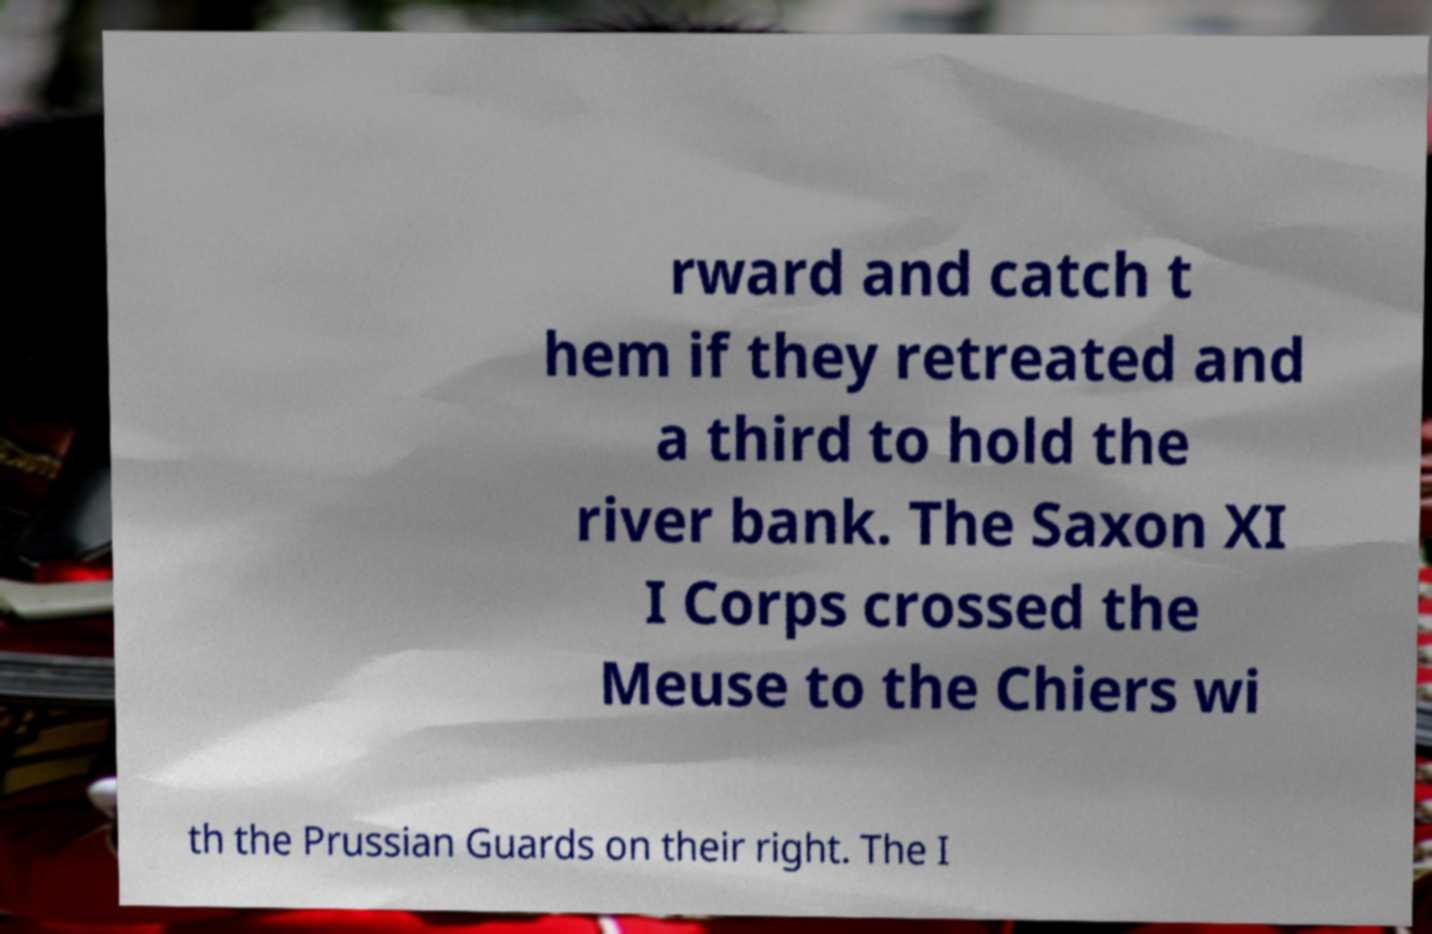There's text embedded in this image that I need extracted. Can you transcribe it verbatim? rward and catch t hem if they retreated and a third to hold the river bank. The Saxon XI I Corps crossed the Meuse to the Chiers wi th the Prussian Guards on their right. The I 